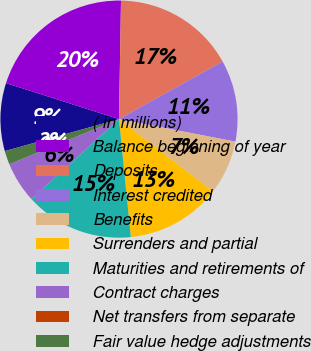Convert chart to OTSL. <chart><loc_0><loc_0><loc_500><loc_500><pie_chart><fcel>( in millions)<fcel>Balance beginning of year<fcel>Deposits<fcel>Interest credited<fcel>Benefits<fcel>Surrenders and partial<fcel>Maturities and retirements of<fcel>Contract charges<fcel>Net transfers from separate<fcel>Fair value hedge adjustments<nl><fcel>9.26%<fcel>20.36%<fcel>16.66%<fcel>11.11%<fcel>7.41%<fcel>12.96%<fcel>14.81%<fcel>5.56%<fcel>0.01%<fcel>1.86%<nl></chart> 